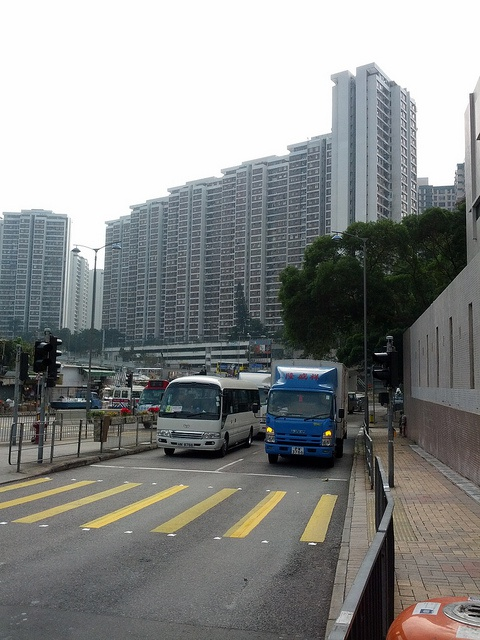Describe the objects in this image and their specific colors. I can see truck in white, black, navy, gray, and blue tones, bus in white, black, gray, darkgray, and darkblue tones, bus in white, black, gray, purple, and maroon tones, traffic light in white, black, gray, lightgray, and darkgray tones, and truck in white, black, darkblue, blue, and gray tones in this image. 